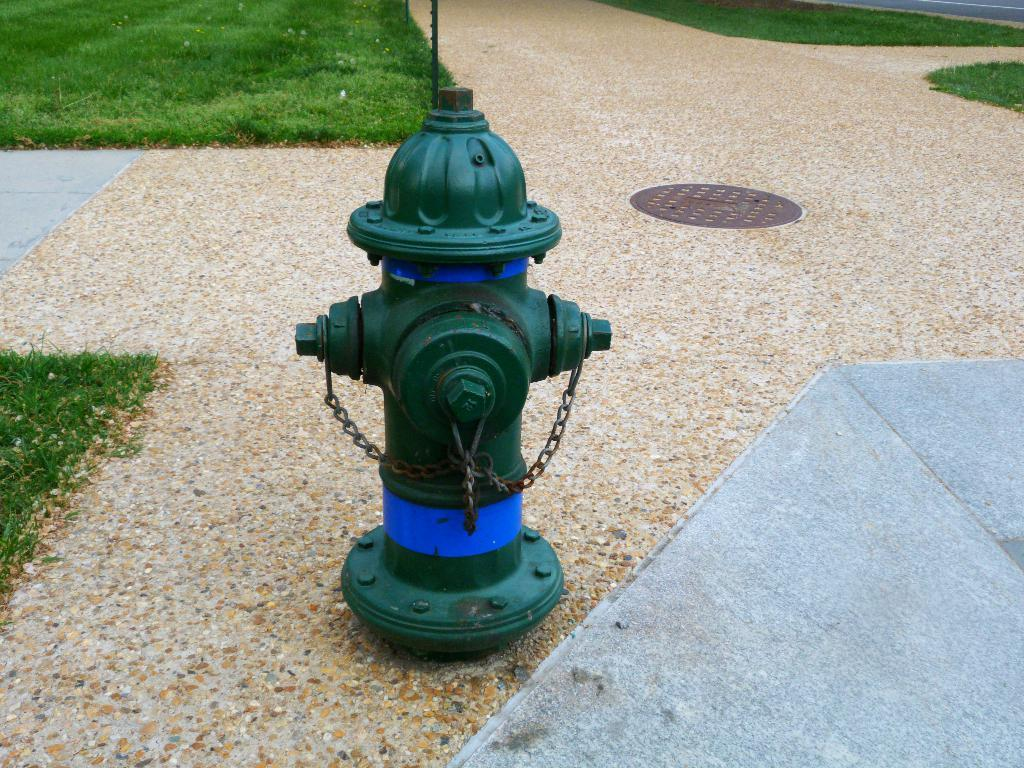What object is located on the ground in the image? There is a fire hydrant on the ground in the image. What type of vegetation can be seen in the image? There is grass visible in the image. What structure is present in the image? There is a pole in the image. What type of surface is visible on the right side of the image? There is a road on the right side of the image. Where is the cactus located in the image? There is no cactus present in the image. What need does the fire hydrant fulfill in the image? The fire hydrant is a stationary object in the image and does not fulfill any specific need within the context of the image. --- Facts: 1. There is a person holding a book in the image. 2. The person is sitting on a chair. 3. There is a table in the image. 4. The table has a lamp on it. 5. There is a window in the background. Absurd Topics: elephant, dance, ocean Conversation: What is the person in the image holding? The person in the image is holding a book. What is the person sitting on in the image? The person is sitting on a chair. What piece of furniture is present in the image? There is a table in the image. What object is on the table in the image? The table has a lamp on it. What can be seen in the background of the image? There is a window in the background. Reasoning: Let's think step by step in order to produce the conversation. We start by identifying the main subject in the image, which is the person holding a book. Then, we expand the conversation to include other items and structures that are also visible, such as the chair, table, lamp, and window. Each question is designed to elicit a specific detail about the image that is known from the provided facts. Absurd Question/Answer: Can you see an elephant dancing in the ocean in the image? No, there is no elephant, dancing, or ocean present in the image. 